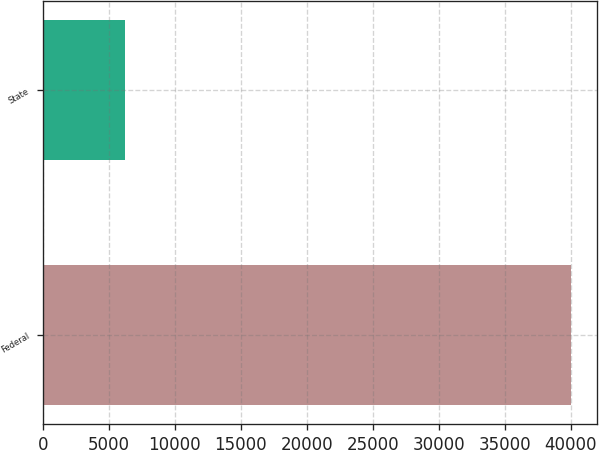Convert chart to OTSL. <chart><loc_0><loc_0><loc_500><loc_500><bar_chart><fcel>Federal<fcel>State<nl><fcel>39994<fcel>6238<nl></chart> 